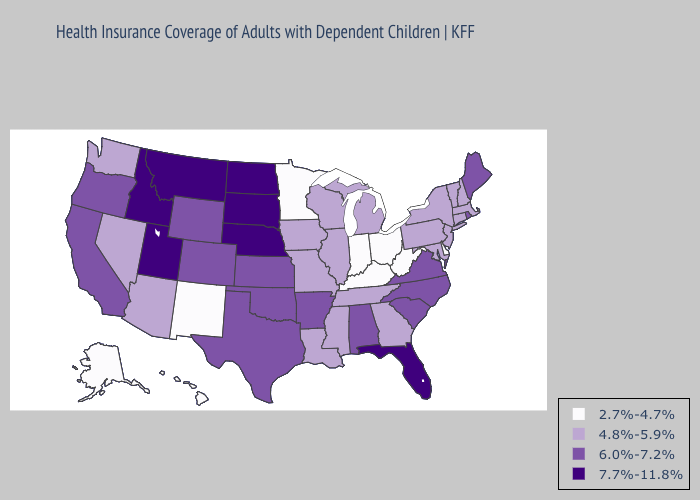Name the states that have a value in the range 6.0%-7.2%?
Answer briefly. Alabama, Arkansas, California, Colorado, Kansas, Maine, North Carolina, Oklahoma, Oregon, Rhode Island, South Carolina, Texas, Virginia, Wyoming. Does Virginia have the lowest value in the South?
Concise answer only. No. What is the value of Vermont?
Concise answer only. 4.8%-5.9%. Name the states that have a value in the range 6.0%-7.2%?
Be succinct. Alabama, Arkansas, California, Colorado, Kansas, Maine, North Carolina, Oklahoma, Oregon, Rhode Island, South Carolina, Texas, Virginia, Wyoming. What is the value of Vermont?
Give a very brief answer. 4.8%-5.9%. Does North Dakota have the highest value in the MidWest?
Write a very short answer. Yes. Name the states that have a value in the range 6.0%-7.2%?
Give a very brief answer. Alabama, Arkansas, California, Colorado, Kansas, Maine, North Carolina, Oklahoma, Oregon, Rhode Island, South Carolina, Texas, Virginia, Wyoming. Does Kentucky have the lowest value in the USA?
Quick response, please. Yes. What is the value of Utah?
Write a very short answer. 7.7%-11.8%. Among the states that border Arkansas , does Texas have the highest value?
Write a very short answer. Yes. What is the value of Ohio?
Keep it brief. 2.7%-4.7%. What is the lowest value in the USA?
Be succinct. 2.7%-4.7%. What is the lowest value in states that border Michigan?
Short answer required. 2.7%-4.7%. Does Indiana have the lowest value in the USA?
Answer briefly. Yes. 